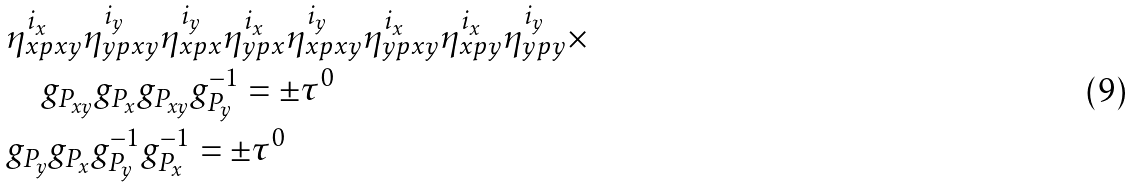<formula> <loc_0><loc_0><loc_500><loc_500>& \eta _ { x p x y } ^ { i _ { x } } \eta _ { y p x y } ^ { i _ { y } } \eta _ { x p x } ^ { i _ { y } } \eta _ { y p x } ^ { i _ { x } } \eta _ { x p x y } ^ { i _ { y } } \eta _ { y p x y } ^ { i _ { x } } \eta _ { x p y } ^ { i _ { x } } \eta _ { y p y } ^ { i _ { y } } \times \\ & \quad g _ { P _ { x y } } g _ { P _ { x } } g _ { P _ { x y } } g _ { P _ { y } } ^ { - 1 } = \pm \tau ^ { 0 } \\ & g _ { P _ { y } } g _ { P _ { x } } g _ { P _ { y } } ^ { - 1 } g _ { P _ { x } } ^ { - 1 } = \pm \tau ^ { 0 }</formula> 